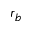<formula> <loc_0><loc_0><loc_500><loc_500>r _ { b }</formula> 